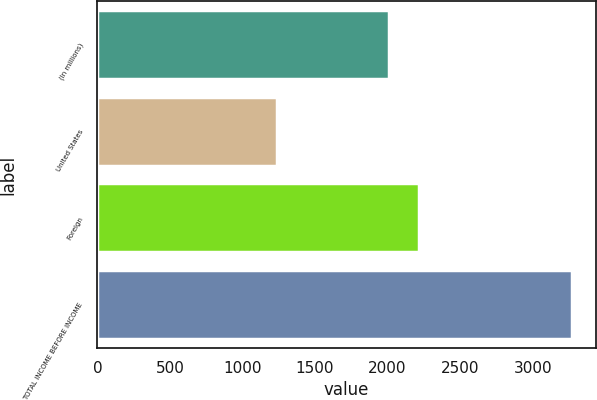Convert chart to OTSL. <chart><loc_0><loc_0><loc_500><loc_500><bar_chart><fcel>(In millions)<fcel>United States<fcel>Foreign<fcel>TOTAL INCOME BEFORE INCOME<nl><fcel>2013<fcel>1240<fcel>2216.2<fcel>3272<nl></chart> 